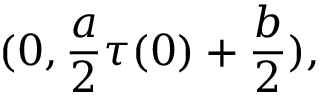Convert formula to latex. <formula><loc_0><loc_0><loc_500><loc_500>( 0 , \frac { a } { 2 } \tau ( 0 ) + \frac { b } { 2 } ) ,</formula> 